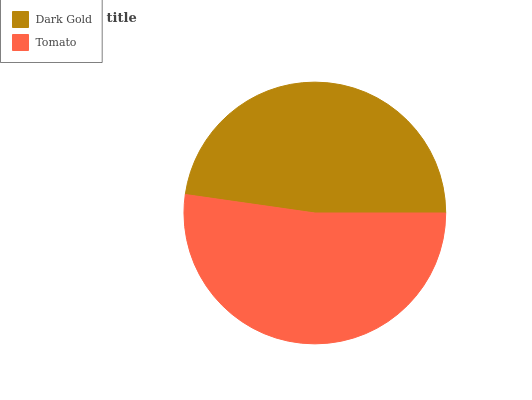Is Dark Gold the minimum?
Answer yes or no. Yes. Is Tomato the maximum?
Answer yes or no. Yes. Is Tomato the minimum?
Answer yes or no. No. Is Tomato greater than Dark Gold?
Answer yes or no. Yes. Is Dark Gold less than Tomato?
Answer yes or no. Yes. Is Dark Gold greater than Tomato?
Answer yes or no. No. Is Tomato less than Dark Gold?
Answer yes or no. No. Is Tomato the high median?
Answer yes or no. Yes. Is Dark Gold the low median?
Answer yes or no. Yes. Is Dark Gold the high median?
Answer yes or no. No. Is Tomato the low median?
Answer yes or no. No. 